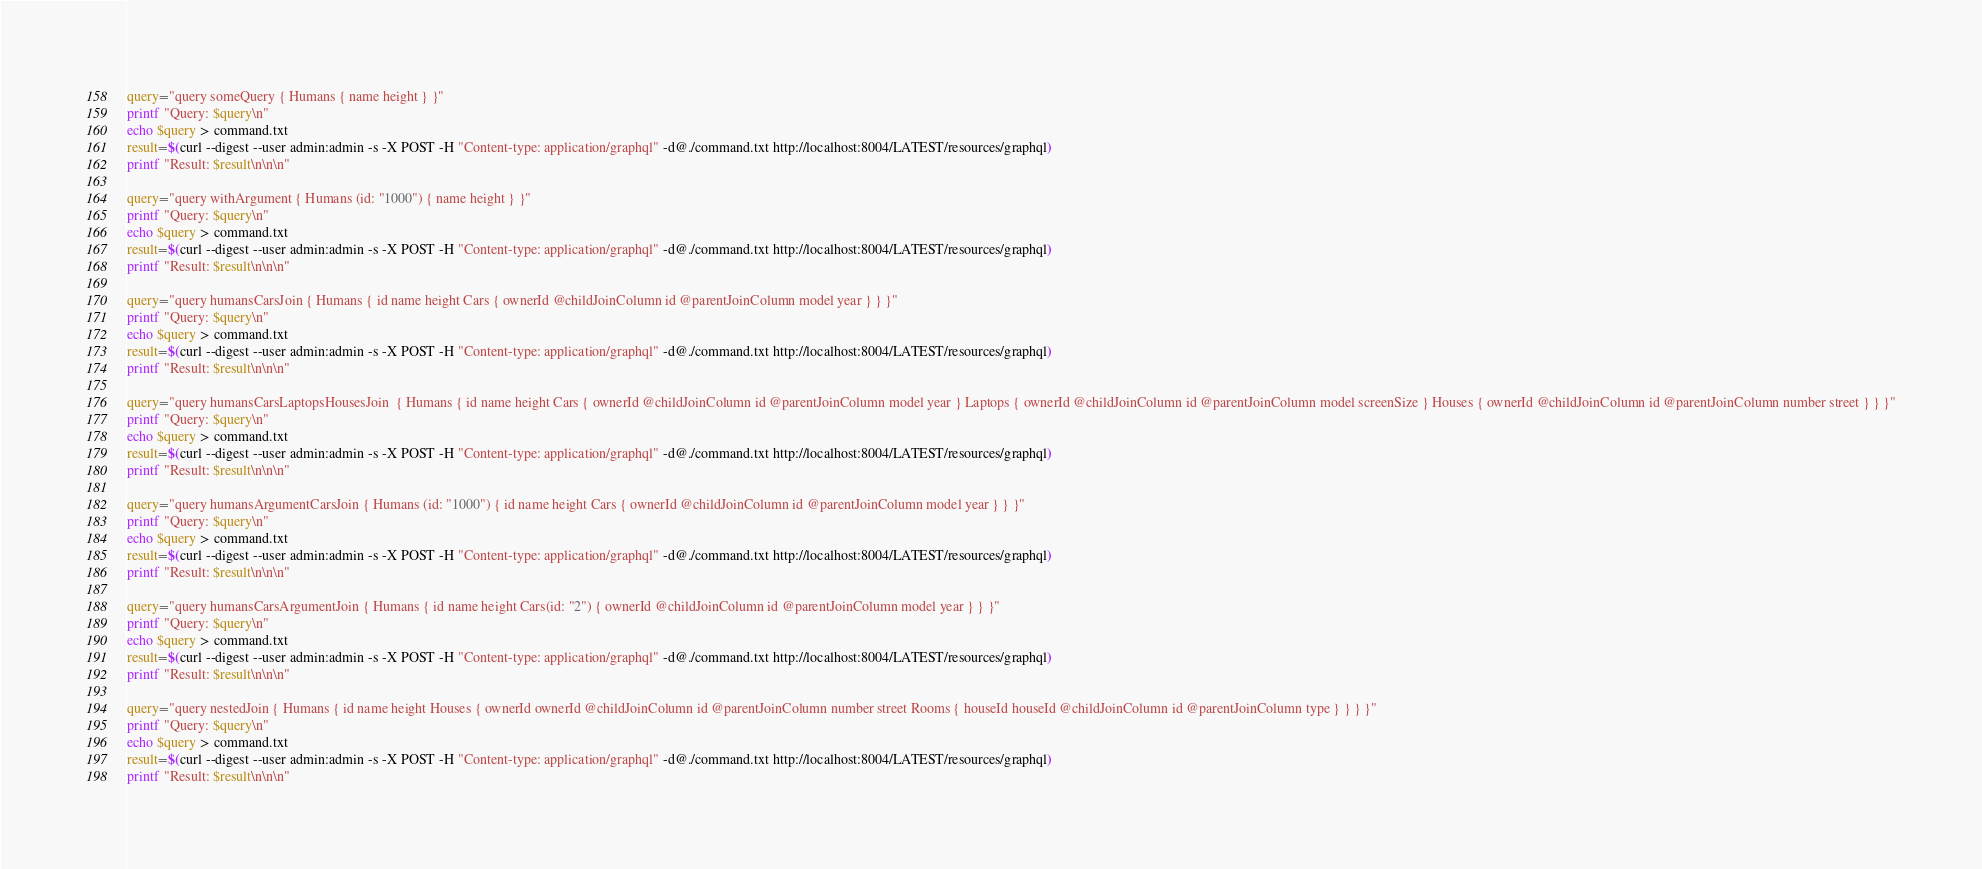Convert code to text. <code><loc_0><loc_0><loc_500><loc_500><_Bash_>query="query someQuery { Humans { name height } }"
printf "Query: $query\n"
echo $query > command.txt
result=$(curl --digest --user admin:admin -s -X POST -H "Content-type: application/graphql" -d@./command.txt http://localhost:8004/LATEST/resources/graphql)
printf "Result: $result\n\n\n"

query="query withArgument { Humans (id: "1000") { name height } }"
printf "Query: $query\n"
echo $query > command.txt
result=$(curl --digest --user admin:admin -s -X POST -H "Content-type: application/graphql" -d@./command.txt http://localhost:8004/LATEST/resources/graphql)
printf "Result: $result\n\n\n"

query="query humansCarsJoin { Humans { id name height Cars { ownerId @childJoinColumn id @parentJoinColumn model year } } }"
printf "Query: $query\n"
echo $query > command.txt
result=$(curl --digest --user admin:admin -s -X POST -H "Content-type: application/graphql" -d@./command.txt http://localhost:8004/LATEST/resources/graphql)
printf "Result: $result\n\n\n"

query="query humansCarsLaptopsHousesJoin  { Humans { id name height Cars { ownerId @childJoinColumn id @parentJoinColumn model year } Laptops { ownerId @childJoinColumn id @parentJoinColumn model screenSize } Houses { ownerId @childJoinColumn id @parentJoinColumn number street } } }"
printf "Query: $query\n"
echo $query > command.txt
result=$(curl --digest --user admin:admin -s -X POST -H "Content-type: application/graphql" -d@./command.txt http://localhost:8004/LATEST/resources/graphql)
printf "Result: $result\n\n\n"

query="query humansArgumentCarsJoin { Humans (id: "1000") { id name height Cars { ownerId @childJoinColumn id @parentJoinColumn model year } } }"
printf "Query: $query\n"
echo $query > command.txt
result=$(curl --digest --user admin:admin -s -X POST -H "Content-type: application/graphql" -d@./command.txt http://localhost:8004/LATEST/resources/graphql)
printf "Result: $result\n\n\n"

query="query humansCarsArgumentJoin { Humans { id name height Cars(id: "2") { ownerId @childJoinColumn id @parentJoinColumn model year } } }"
printf "Query: $query\n"
echo $query > command.txt
result=$(curl --digest --user admin:admin -s -X POST -H "Content-type: application/graphql" -d@./command.txt http://localhost:8004/LATEST/resources/graphql)
printf "Result: $result\n\n\n"

query="query nestedJoin { Humans { id name height Houses { ownerId ownerId @childJoinColumn id @parentJoinColumn number street Rooms { houseId houseId @childJoinColumn id @parentJoinColumn type } } } }"
printf "Query: $query\n"
echo $query > command.txt
result=$(curl --digest --user admin:admin -s -X POST -H "Content-type: application/graphql" -d@./command.txt http://localhost:8004/LATEST/resources/graphql)
printf "Result: $result\n\n\n"
</code> 